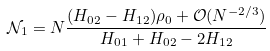<formula> <loc_0><loc_0><loc_500><loc_500>\mathcal { N } _ { 1 } = N \frac { ( H _ { 0 2 } - H _ { 1 2 } ) \rho _ { 0 } + \mathcal { O } ( N ^ { - 2 / 3 } ) } { H _ { 0 1 } + H _ { 0 2 } - 2 H _ { 1 2 } }</formula> 